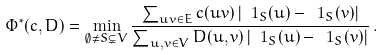Convert formula to latex. <formula><loc_0><loc_0><loc_500><loc_500>\Phi ^ { * } ( c , D ) = \min _ { \emptyset \neq S \subsetneq V } \frac { \sum _ { u v \in E } c ( u v ) \left | \ 1 _ { S } ( u ) - \ 1 _ { S } ( v ) \right | } { \sum _ { u , v \in V } D ( u , v ) \left | \ 1 _ { S } ( u ) - \ 1 _ { S } ( v ) \right | } \, .</formula> 